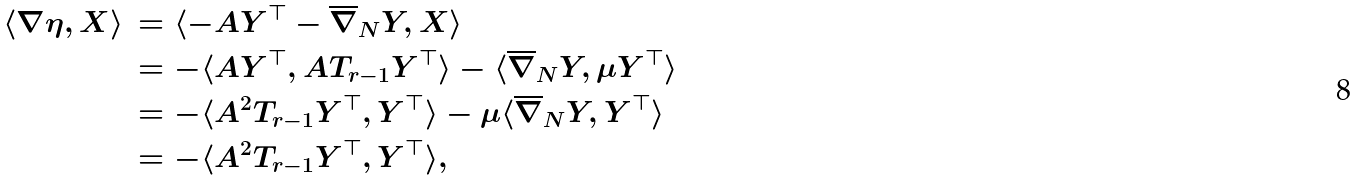Convert formula to latex. <formula><loc_0><loc_0><loc_500><loc_500>\langle \nabla \eta , X \rangle & \, = \langle - A Y ^ { \top } - \overline { \nabla } _ { N } Y , X \rangle \\ & \, = - \langle A Y ^ { \top } , A T _ { r - 1 } Y ^ { \top } \rangle - \langle \overline { \nabla } _ { N } Y , \mu Y ^ { \top } \rangle \\ & \, = - \langle A ^ { 2 } T _ { r - 1 } Y ^ { \top } , Y ^ { \top } \rangle - \mu \langle \overline { \nabla } _ { N } Y , Y ^ { \top } \rangle \\ & \, = - \langle A ^ { 2 } T _ { r - 1 } Y ^ { \top } , Y ^ { \top } \rangle ,</formula> 